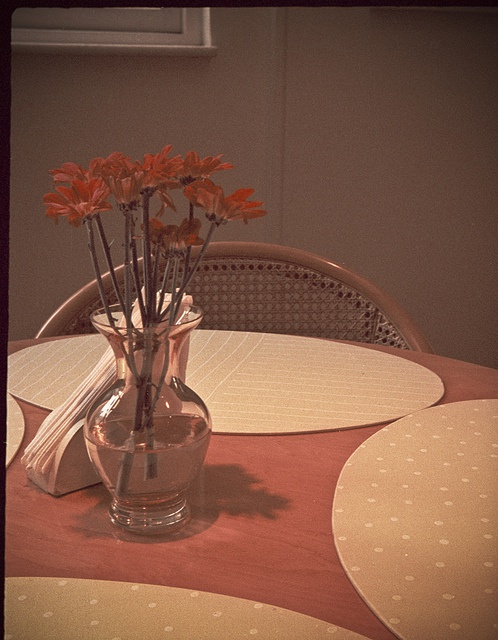Describe the objects in this image and their specific colors. I can see dining table in black, brown, and tan tones, vase in black, brown, and maroon tones, and chair in black, maroon, and brown tones in this image. 